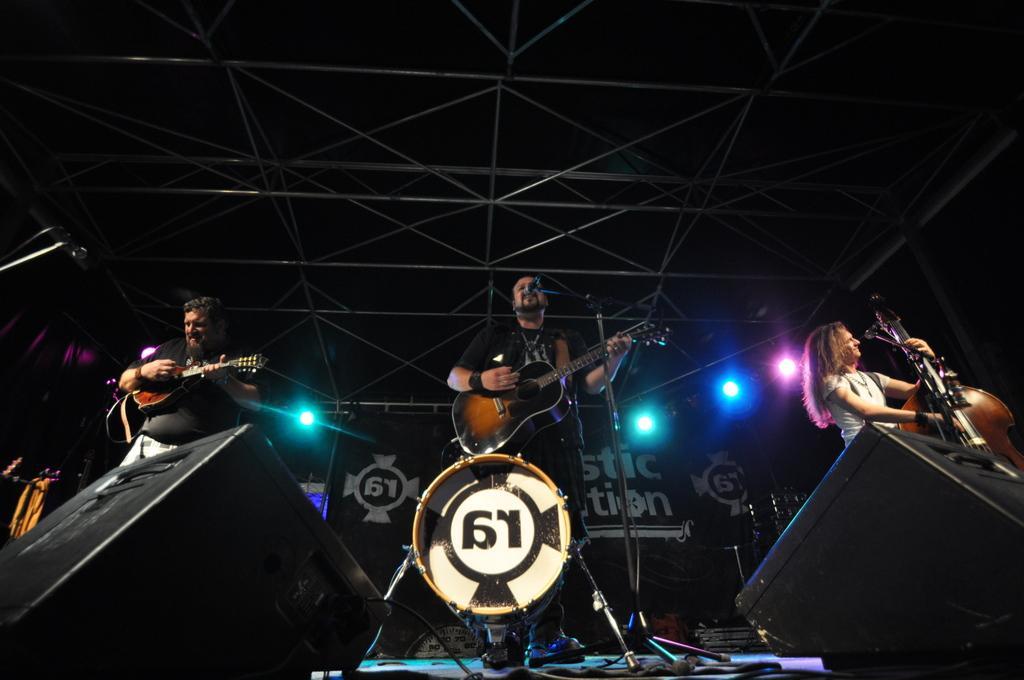How would you summarize this image in a sentence or two? there are so many people standing on a stage playing a guitar behind them there are big sound boxes. 